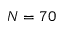<formula> <loc_0><loc_0><loc_500><loc_500>N = 7 0</formula> 